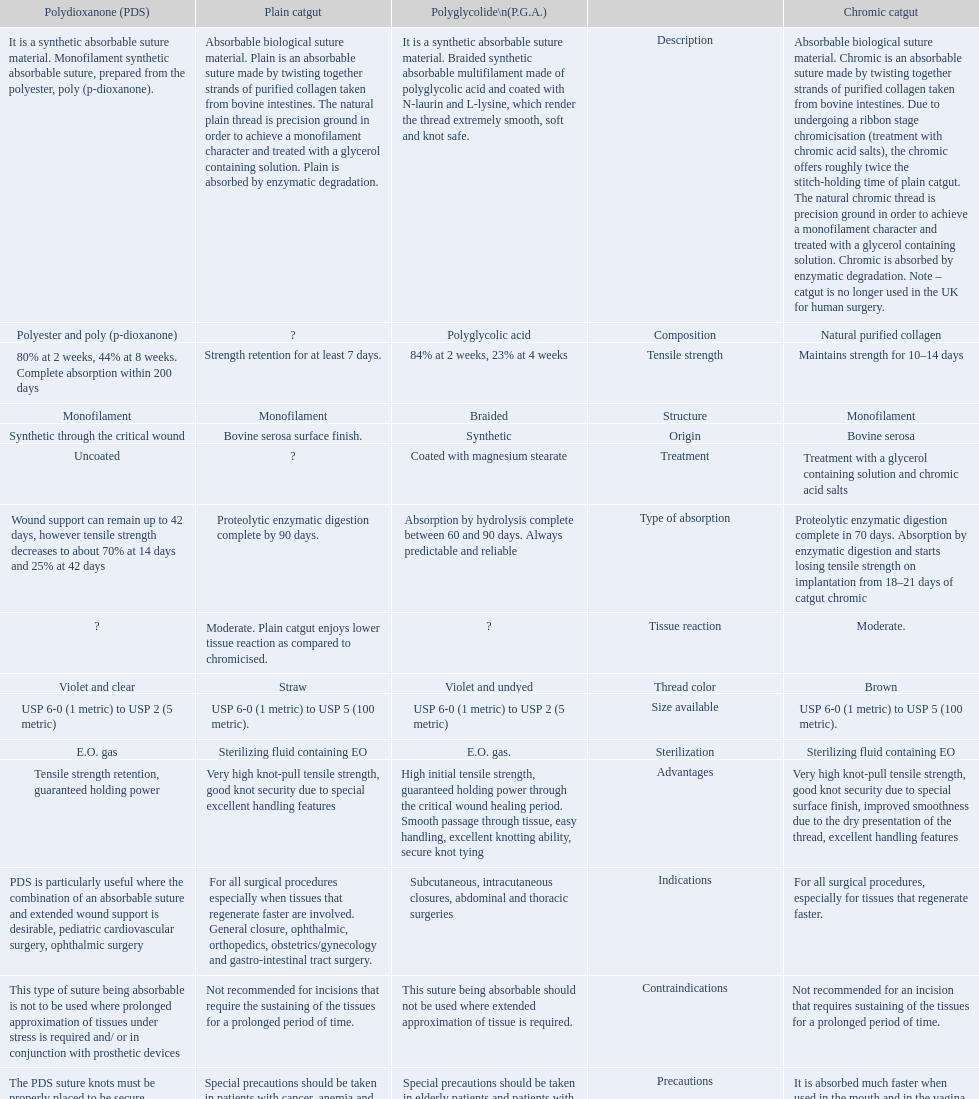What is the structure other than monofilament Braided. 